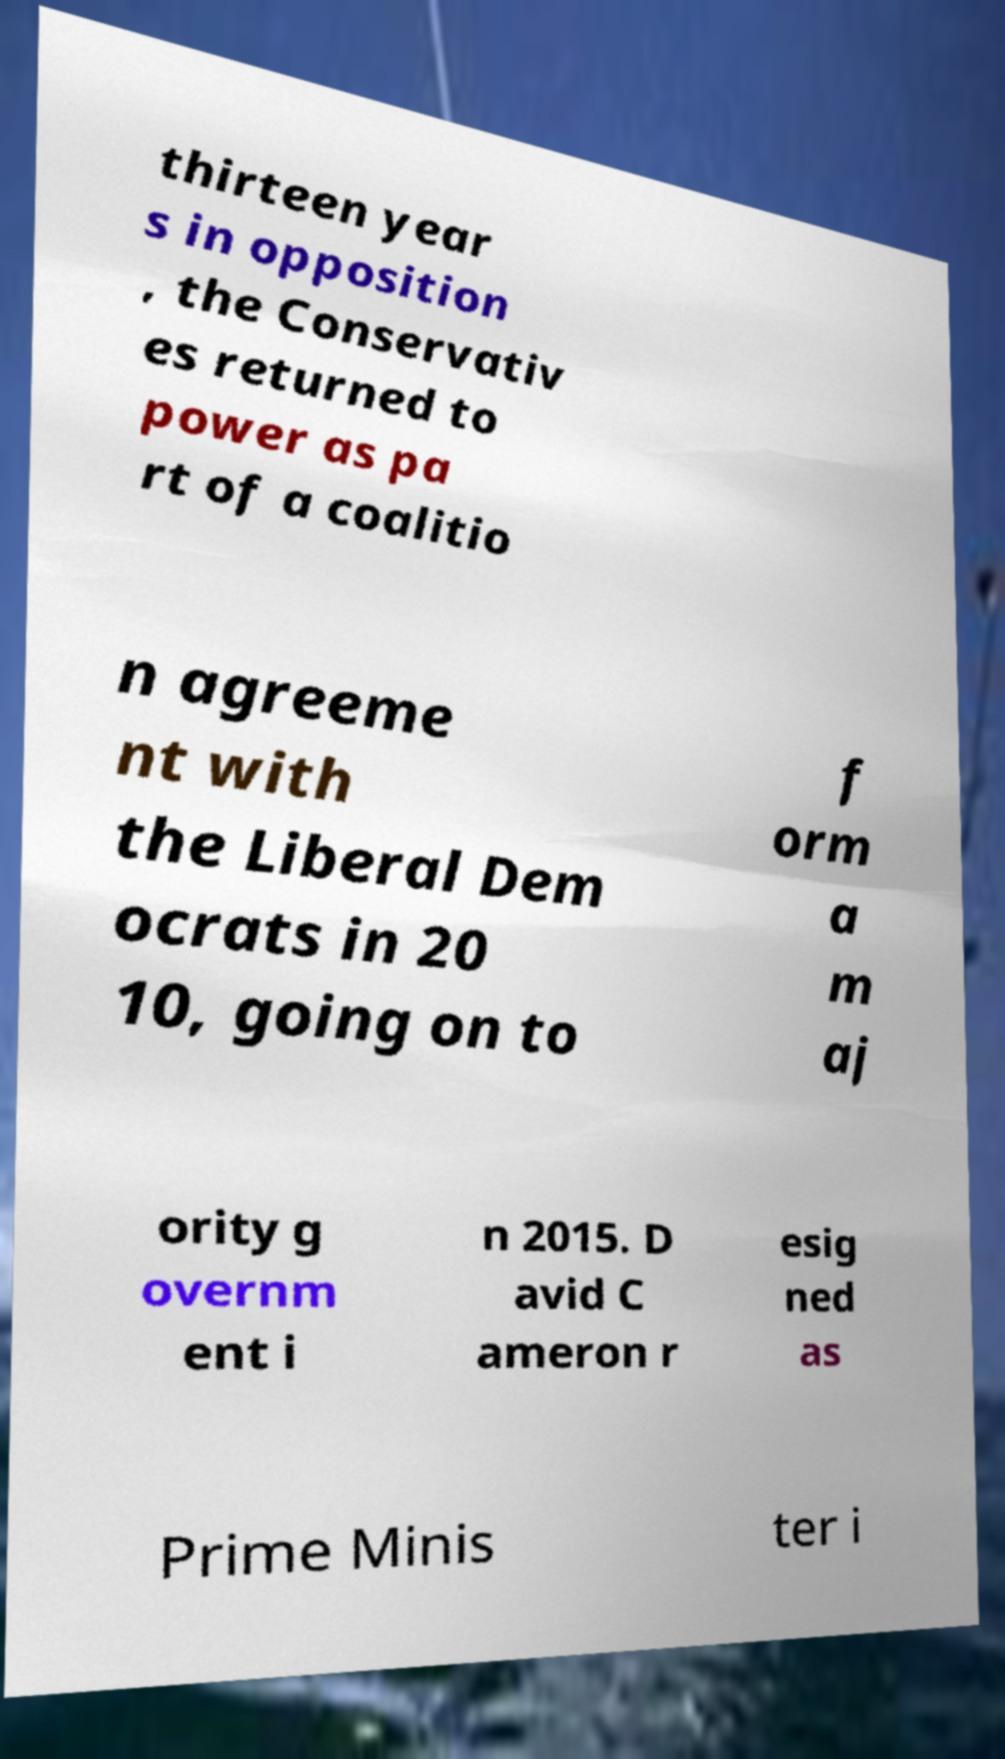What messages or text are displayed in this image? I need them in a readable, typed format. thirteen year s in opposition , the Conservativ es returned to power as pa rt of a coalitio n agreeme nt with the Liberal Dem ocrats in 20 10, going on to f orm a m aj ority g overnm ent i n 2015. D avid C ameron r esig ned as Prime Minis ter i 